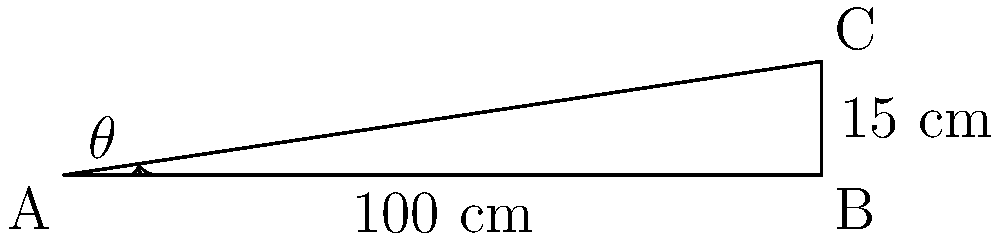As a consumer advocate working on accessibility standards, you're reviewing a proposed wheelchair ramp design. The ramp is 100 cm long and rises 15 cm. What is the angle of inclination (θ) of this ramp, and does it meet the ADA (Americans with Disabilities Act) standard of a maximum 1:12 slope (approximately 4.8 degrees)? To solve this problem, we'll follow these steps:

1) First, we need to calculate the angle of inclination (θ) using trigonometry.

2) In this right-angled triangle:
   - The adjacent side (ramp length) is 100 cm
   - The opposite side (ramp height) is 15 cm

3) We can use the tangent function to find θ:

   $$\tan(\theta) = \frac{\text{opposite}}{\text{adjacent}} = \frac{15}{100} = 0.15$$

4) To find θ, we take the inverse tangent (arctan):

   $$\theta = \arctan(0.15) \approx 8.53\text{ degrees}$$

5) Now, let's compare this to the ADA standard:
   - ADA standard maximum slope: 1:12 (rise:run)
   - This is equivalent to $\arctan(\frac{1}{12}) \approx 4.76\text{ degrees}$

6) 8.53 degrees > 4.76 degrees, so this ramp does not meet the ADA standard.

As a consumer advocate, you should report that this ramp design exceeds the maximum allowable slope and recommend redesigning it to meet the 1:12 slope requirement for accessibility.
Answer: 8.53°; does not meet ADA standard 